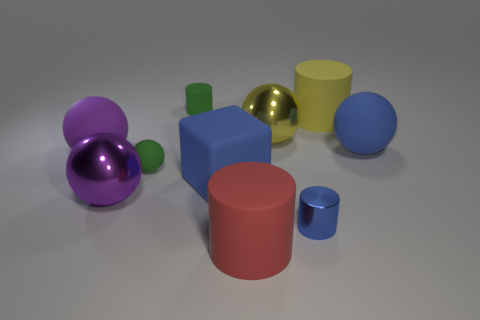What is the shape of the rubber object that is the same color as the large matte block?
Offer a very short reply. Sphere. What number of big green things are there?
Your response must be concise. 0. Do the tiny cylinder that is on the left side of the large red rubber cylinder and the large blue thing right of the red object have the same material?
Provide a short and direct response. Yes. There is a blue sphere that is made of the same material as the big blue cube; what is its size?
Offer a terse response. Large. There is a tiny thing that is to the right of the red matte cylinder; what is its shape?
Make the answer very short. Cylinder. Does the small cylinder that is left of the blue shiny cylinder have the same color as the metallic thing that is right of the big yellow shiny sphere?
Your response must be concise. No. What is the size of the matte sphere that is the same color as the metallic cylinder?
Your answer should be very brief. Large. Is there a shiny thing?
Offer a very short reply. Yes. There is a blue matte thing in front of the small matte object that is to the left of the small green matte object behind the big yellow metal sphere; what shape is it?
Make the answer very short. Cube. What number of blue matte objects are behind the small ball?
Your answer should be very brief. 1. 